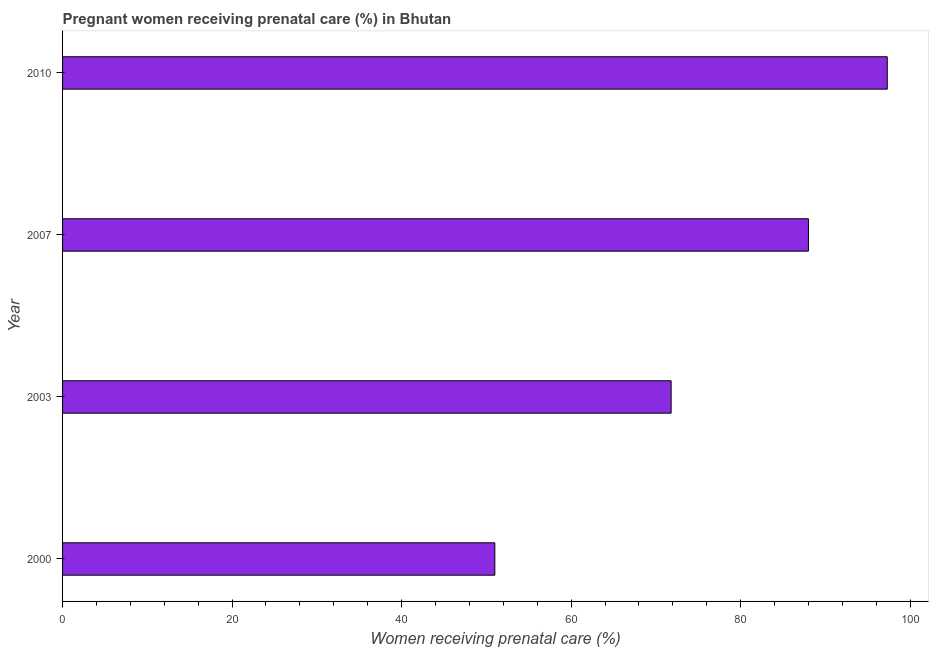Does the graph contain grids?
Make the answer very short. No. What is the title of the graph?
Provide a succinct answer. Pregnant women receiving prenatal care (%) in Bhutan. What is the label or title of the X-axis?
Offer a very short reply. Women receiving prenatal care (%). What is the percentage of pregnant women receiving prenatal care in 2010?
Your answer should be compact. 97.3. Across all years, what is the maximum percentage of pregnant women receiving prenatal care?
Your answer should be compact. 97.3. Across all years, what is the minimum percentage of pregnant women receiving prenatal care?
Provide a succinct answer. 51. In which year was the percentage of pregnant women receiving prenatal care maximum?
Offer a very short reply. 2010. What is the sum of the percentage of pregnant women receiving prenatal care?
Your answer should be very brief. 308.1. What is the difference between the percentage of pregnant women receiving prenatal care in 2003 and 2007?
Make the answer very short. -16.2. What is the average percentage of pregnant women receiving prenatal care per year?
Your response must be concise. 77.03. What is the median percentage of pregnant women receiving prenatal care?
Your response must be concise. 79.9. In how many years, is the percentage of pregnant women receiving prenatal care greater than 68 %?
Your answer should be compact. 3. What is the ratio of the percentage of pregnant women receiving prenatal care in 2000 to that in 2010?
Ensure brevity in your answer.  0.52. Is the percentage of pregnant women receiving prenatal care in 2000 less than that in 2007?
Provide a succinct answer. Yes. What is the difference between the highest and the lowest percentage of pregnant women receiving prenatal care?
Offer a very short reply. 46.3. In how many years, is the percentage of pregnant women receiving prenatal care greater than the average percentage of pregnant women receiving prenatal care taken over all years?
Make the answer very short. 2. How many bars are there?
Keep it short and to the point. 4. What is the Women receiving prenatal care (%) in 2003?
Give a very brief answer. 71.8. What is the Women receiving prenatal care (%) in 2007?
Make the answer very short. 88. What is the Women receiving prenatal care (%) in 2010?
Ensure brevity in your answer.  97.3. What is the difference between the Women receiving prenatal care (%) in 2000 and 2003?
Provide a succinct answer. -20.8. What is the difference between the Women receiving prenatal care (%) in 2000 and 2007?
Offer a terse response. -37. What is the difference between the Women receiving prenatal care (%) in 2000 and 2010?
Your answer should be very brief. -46.3. What is the difference between the Women receiving prenatal care (%) in 2003 and 2007?
Offer a very short reply. -16.2. What is the difference between the Women receiving prenatal care (%) in 2003 and 2010?
Ensure brevity in your answer.  -25.5. What is the difference between the Women receiving prenatal care (%) in 2007 and 2010?
Keep it short and to the point. -9.3. What is the ratio of the Women receiving prenatal care (%) in 2000 to that in 2003?
Your answer should be compact. 0.71. What is the ratio of the Women receiving prenatal care (%) in 2000 to that in 2007?
Your answer should be very brief. 0.58. What is the ratio of the Women receiving prenatal care (%) in 2000 to that in 2010?
Give a very brief answer. 0.52. What is the ratio of the Women receiving prenatal care (%) in 2003 to that in 2007?
Provide a succinct answer. 0.82. What is the ratio of the Women receiving prenatal care (%) in 2003 to that in 2010?
Keep it short and to the point. 0.74. What is the ratio of the Women receiving prenatal care (%) in 2007 to that in 2010?
Provide a short and direct response. 0.9. 